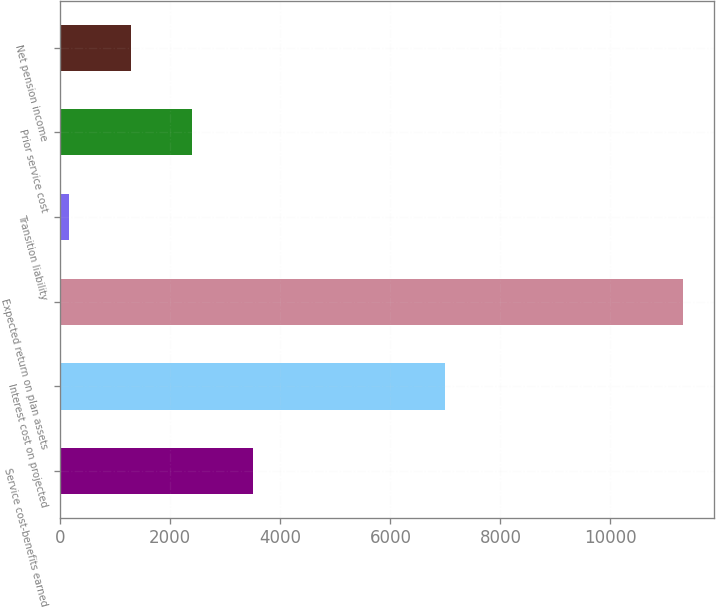Convert chart. <chart><loc_0><loc_0><loc_500><loc_500><bar_chart><fcel>Service cost-benefits earned<fcel>Interest cost on projected<fcel>Expected return on plan assets<fcel>Transition liability<fcel>Prior service cost<fcel>Net pension income<nl><fcel>3508.4<fcel>6990<fcel>11312<fcel>164<fcel>2393.6<fcel>1278.8<nl></chart> 